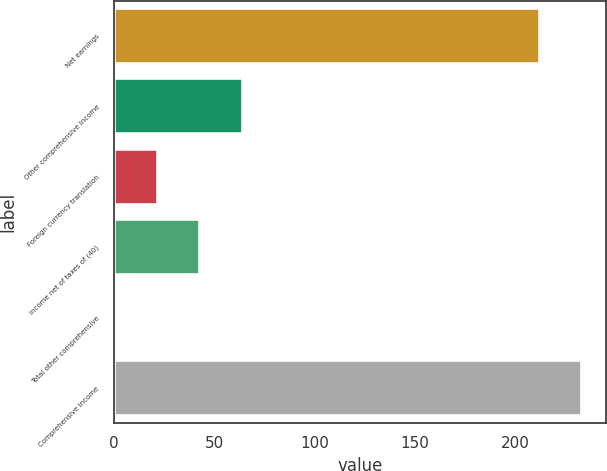<chart> <loc_0><loc_0><loc_500><loc_500><bar_chart><fcel>Net earnings<fcel>Other comprehensive income<fcel>Foreign currency translation<fcel>income net of taxes of (40)<fcel>Total other comprehensive<fcel>Comprehensive income<nl><fcel>212.1<fcel>64.33<fcel>21.91<fcel>43.12<fcel>0.7<fcel>233.31<nl></chart> 